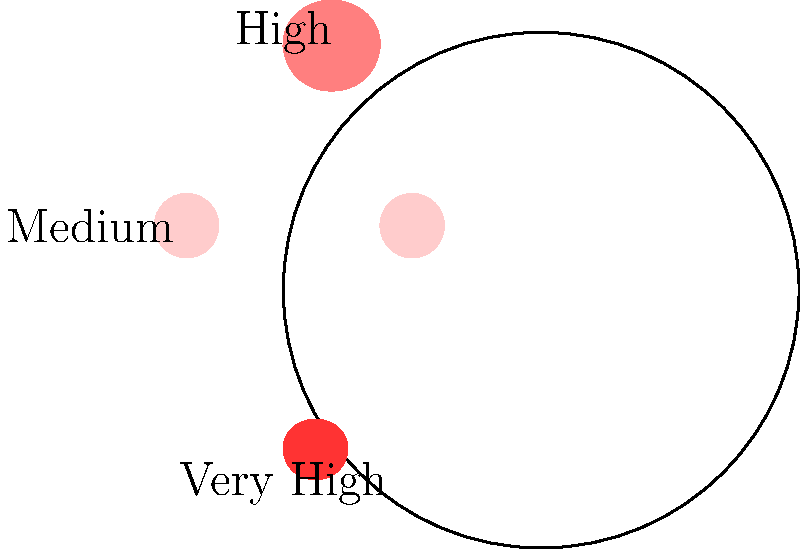During a particularly emotional segment of Cristina Morán's talk show, facial expression heat maps were used to analyze audience reactions. Based on the heat map shown, which facial feature exhibited the strongest emotional response? To answer this question, we need to analyze the facial expression heat map provided:

1. The heat map uses color intensity to represent the strength of emotional responses in different facial regions.
2. The color scale ranges from light pink (low intensity) to dark red (high intensity).
3. We can observe four main regions on the face:
   a. Forehead: medium intensity (light red)
   b. Eyes: low intensity (very light pink)
   c. Mouth area: highest intensity (dark red)
   d. Cheeks: not highlighted, indicating low or no significant response

4. The mouth area shows the darkest shade of red, indicating the strongest emotional response.
5. This is consistent with many emotional expressions where the mouth plays a crucial role (e.g., smiling, frowning, gasping).

6. In contrast, other facial features show less intense responses:
   - The forehead shows a moderate response
   - The eyes show minimal response
   - The cheeks don't show any significant response

Therefore, based on this heat map, the mouth area exhibited the strongest emotional response during Cristina Morán's performance.
Answer: Mouth 